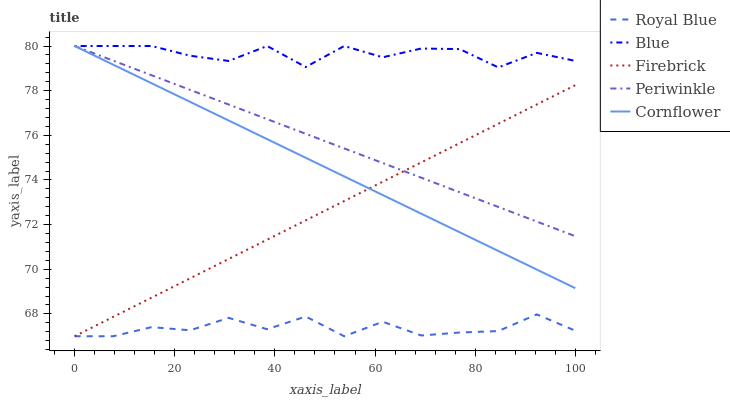Does Royal Blue have the minimum area under the curve?
Answer yes or no. Yes. Does Blue have the maximum area under the curve?
Answer yes or no. Yes. Does Firebrick have the minimum area under the curve?
Answer yes or no. No. Does Firebrick have the maximum area under the curve?
Answer yes or no. No. Is Cornflower the smoothest?
Answer yes or no. Yes. Is Blue the roughest?
Answer yes or no. Yes. Is Royal Blue the smoothest?
Answer yes or no. No. Is Royal Blue the roughest?
Answer yes or no. No. Does Royal Blue have the lowest value?
Answer yes or no. Yes. Does Periwinkle have the lowest value?
Answer yes or no. No. Does Cornflower have the highest value?
Answer yes or no. Yes. Does Firebrick have the highest value?
Answer yes or no. No. Is Royal Blue less than Periwinkle?
Answer yes or no. Yes. Is Blue greater than Firebrick?
Answer yes or no. Yes. Does Firebrick intersect Cornflower?
Answer yes or no. Yes. Is Firebrick less than Cornflower?
Answer yes or no. No. Is Firebrick greater than Cornflower?
Answer yes or no. No. Does Royal Blue intersect Periwinkle?
Answer yes or no. No. 